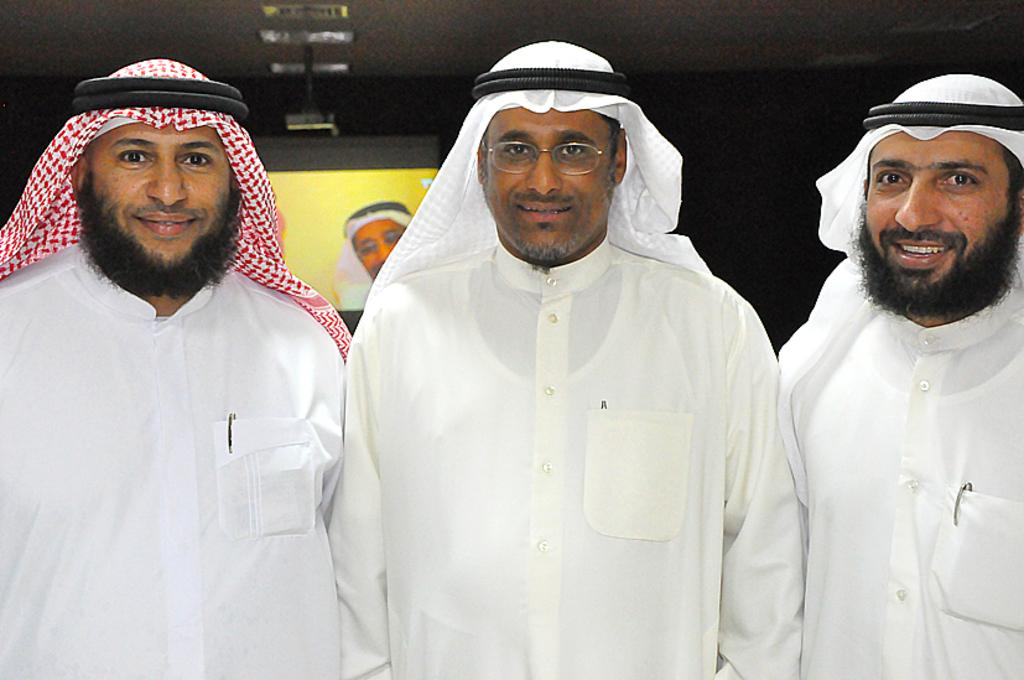How many people are in the image? There are three persons in the image. What are the persons doing in the image? The persons are standing and smiling. What can be seen in the background of the image? There is a display screen in the background of the image. What is visible above the persons in the image? There is a ceiling with lights visible in the image. What type of animal can be seen on the display screen in the image? There is no animal visible on the display screen in the image. What room are the persons standing in, as indicated by the image? The image does not provide information about the room where the persons are standing. 